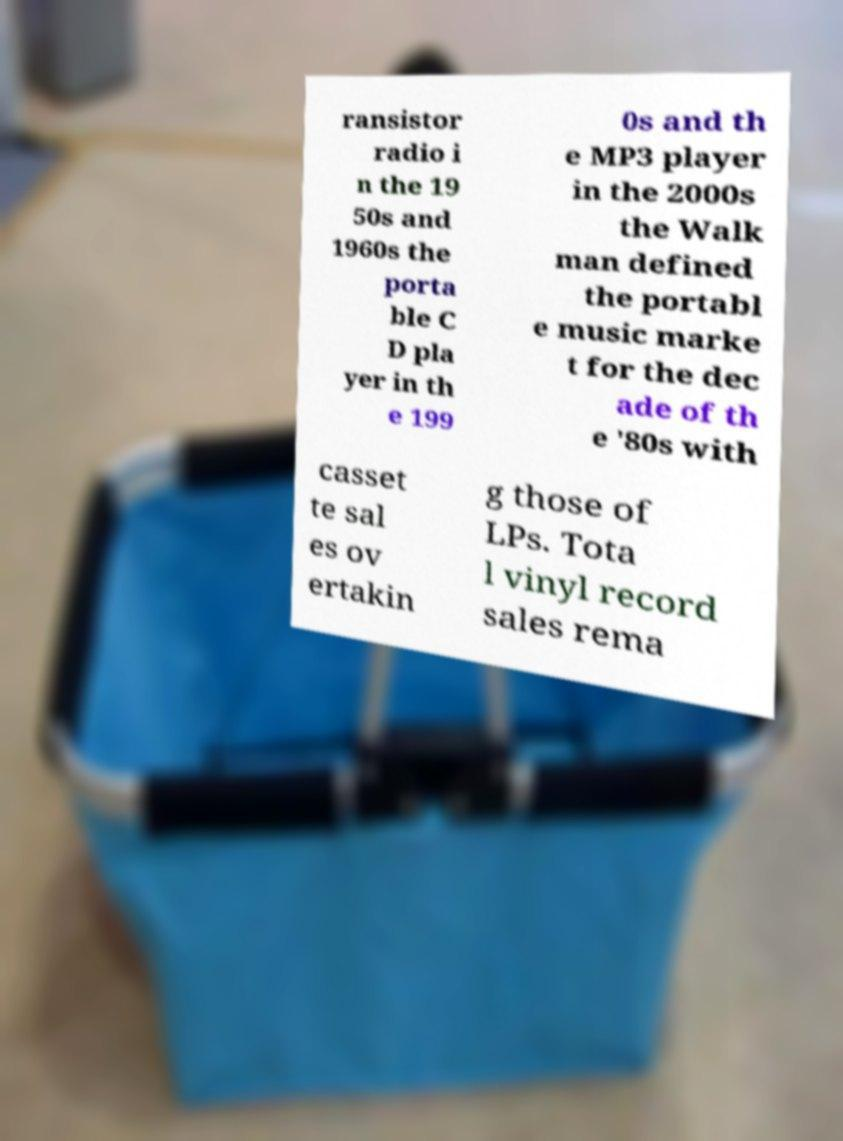For documentation purposes, I need the text within this image transcribed. Could you provide that? ransistor radio i n the 19 50s and 1960s the porta ble C D pla yer in th e 199 0s and th e MP3 player in the 2000s the Walk man defined the portabl e music marke t for the dec ade of th e '80s with casset te sal es ov ertakin g those of LPs. Tota l vinyl record sales rema 